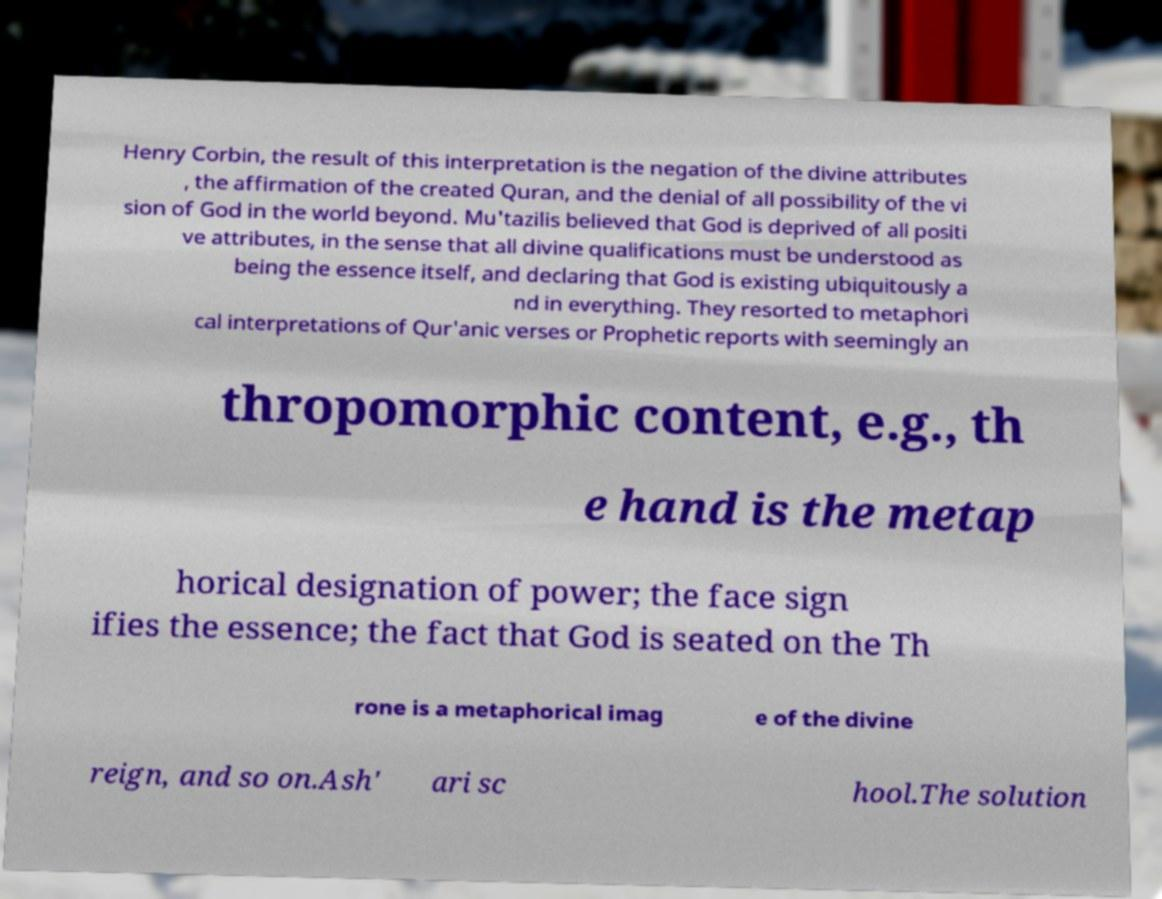For documentation purposes, I need the text within this image transcribed. Could you provide that? Henry Corbin, the result of this interpretation is the negation of the divine attributes , the affirmation of the created Quran, and the denial of all possibility of the vi sion of God in the world beyond. Mu'tazilis believed that God is deprived of all positi ve attributes, in the sense that all divine qualifications must be understood as being the essence itself, and declaring that God is existing ubiquitously a nd in everything. They resorted to metaphori cal interpretations of Qur'anic verses or Prophetic reports with seemingly an thropomorphic content, e.g., th e hand is the metap horical designation of power; the face sign ifies the essence; the fact that God is seated on the Th rone is a metaphorical imag e of the divine reign, and so on.Ash' ari sc hool.The solution 